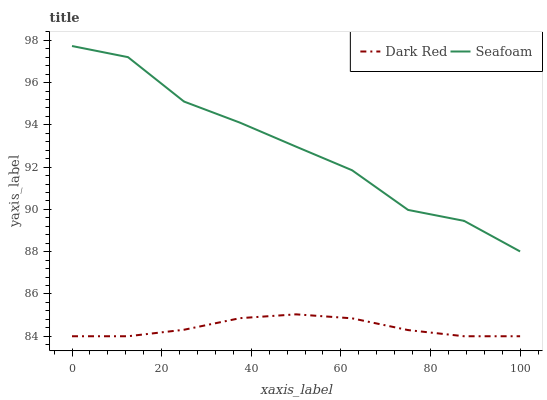Does Seafoam have the minimum area under the curve?
Answer yes or no. No. Is Seafoam the smoothest?
Answer yes or no. No. Does Seafoam have the lowest value?
Answer yes or no. No. Is Dark Red less than Seafoam?
Answer yes or no. Yes. Is Seafoam greater than Dark Red?
Answer yes or no. Yes. Does Dark Red intersect Seafoam?
Answer yes or no. No. 